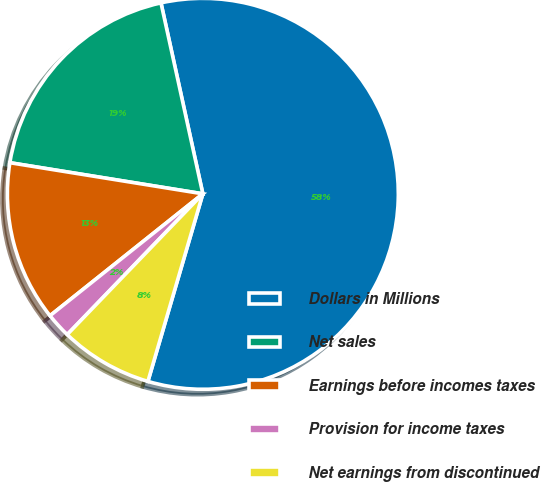Convert chart. <chart><loc_0><loc_0><loc_500><loc_500><pie_chart><fcel>Dollars in Millions<fcel>Net sales<fcel>Earnings before incomes taxes<fcel>Provision for income taxes<fcel>Net earnings from discontinued<nl><fcel>57.97%<fcel>19.02%<fcel>13.26%<fcel>2.08%<fcel>7.67%<nl></chart> 